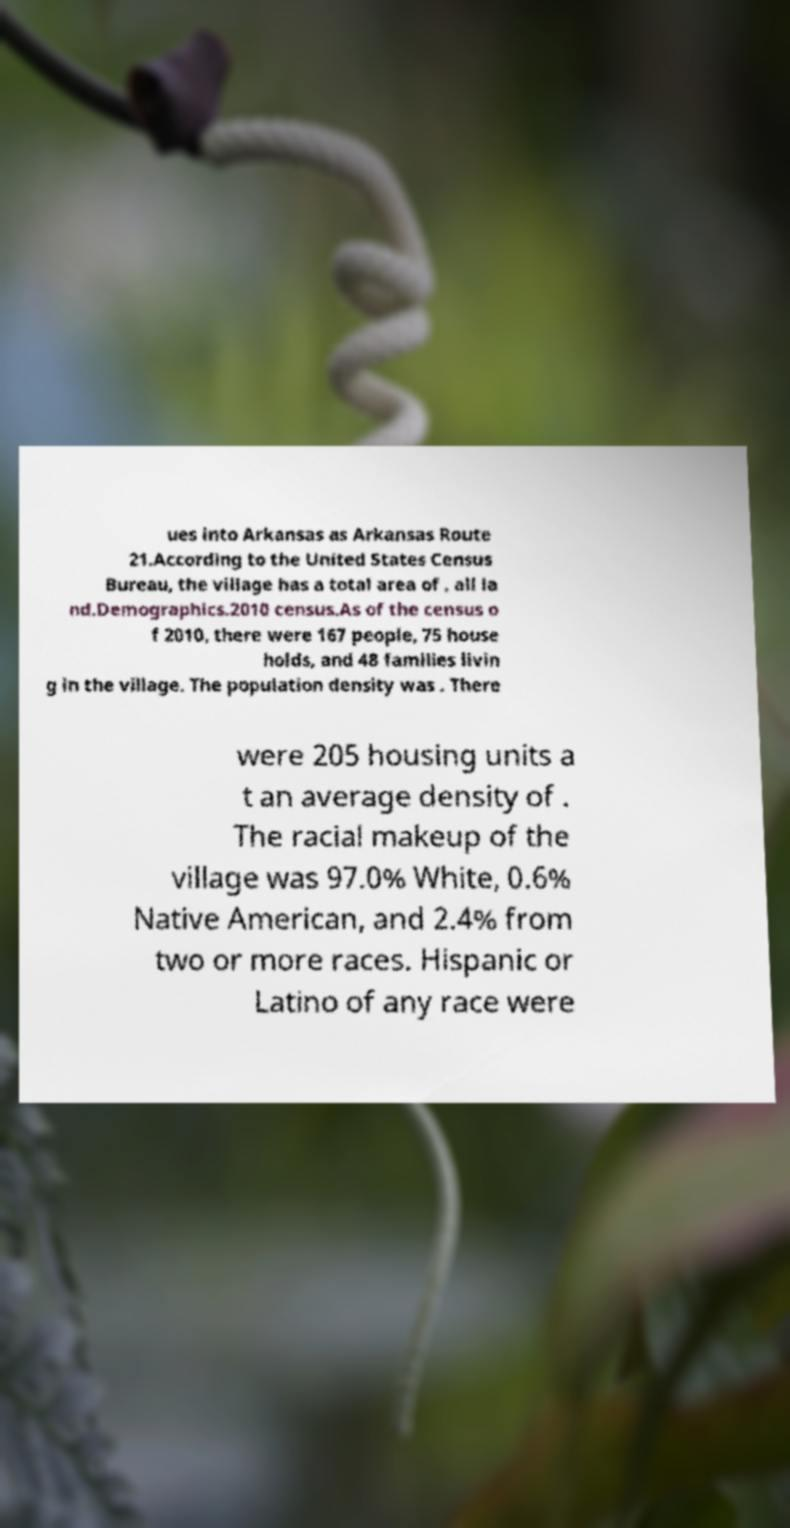Could you assist in decoding the text presented in this image and type it out clearly? ues into Arkansas as Arkansas Route 21.According to the United States Census Bureau, the village has a total area of , all la nd.Demographics.2010 census.As of the census o f 2010, there were 167 people, 75 house holds, and 48 families livin g in the village. The population density was . There were 205 housing units a t an average density of . The racial makeup of the village was 97.0% White, 0.6% Native American, and 2.4% from two or more races. Hispanic or Latino of any race were 